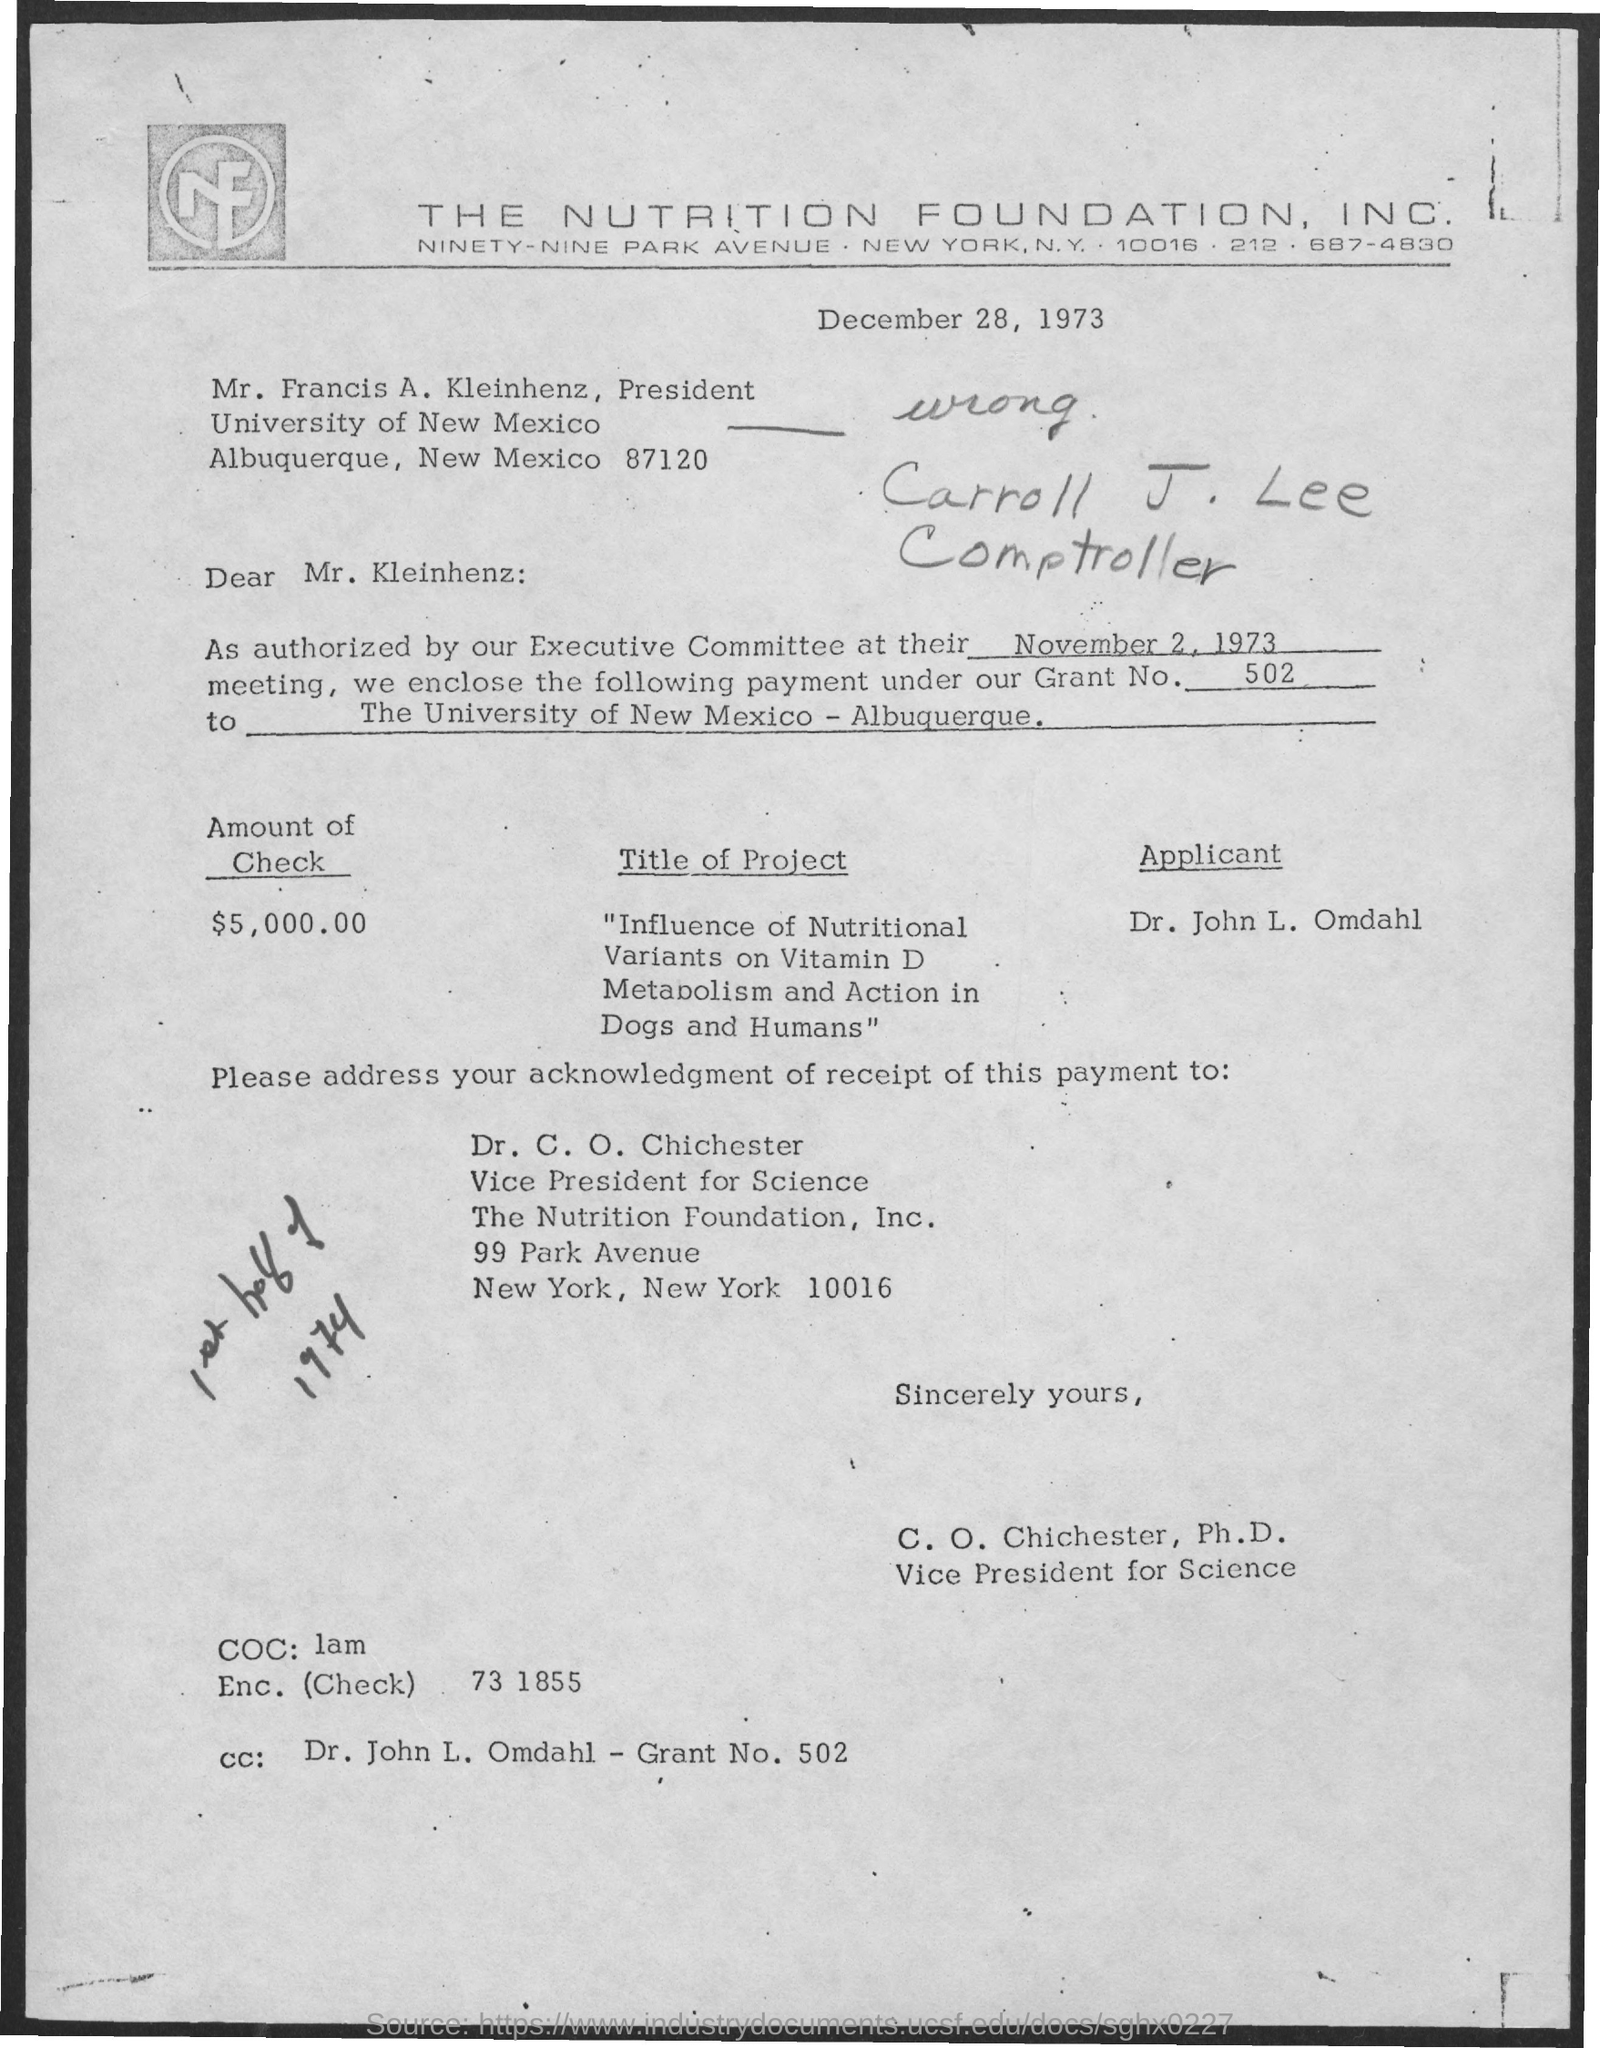Indicate a few pertinent items in this graphic. The University of New Mexico is mentioned in the given letter. The grant number mentioned in the given letter is 502. The designation of C.O. Chichester is Vice President for Science. The amount of the check mentioned in the letter is $5,000.00. The title of the project is "Influence of Nutritional Variants on Vitamin D Metabolism and Action in Dogs and Humans. 